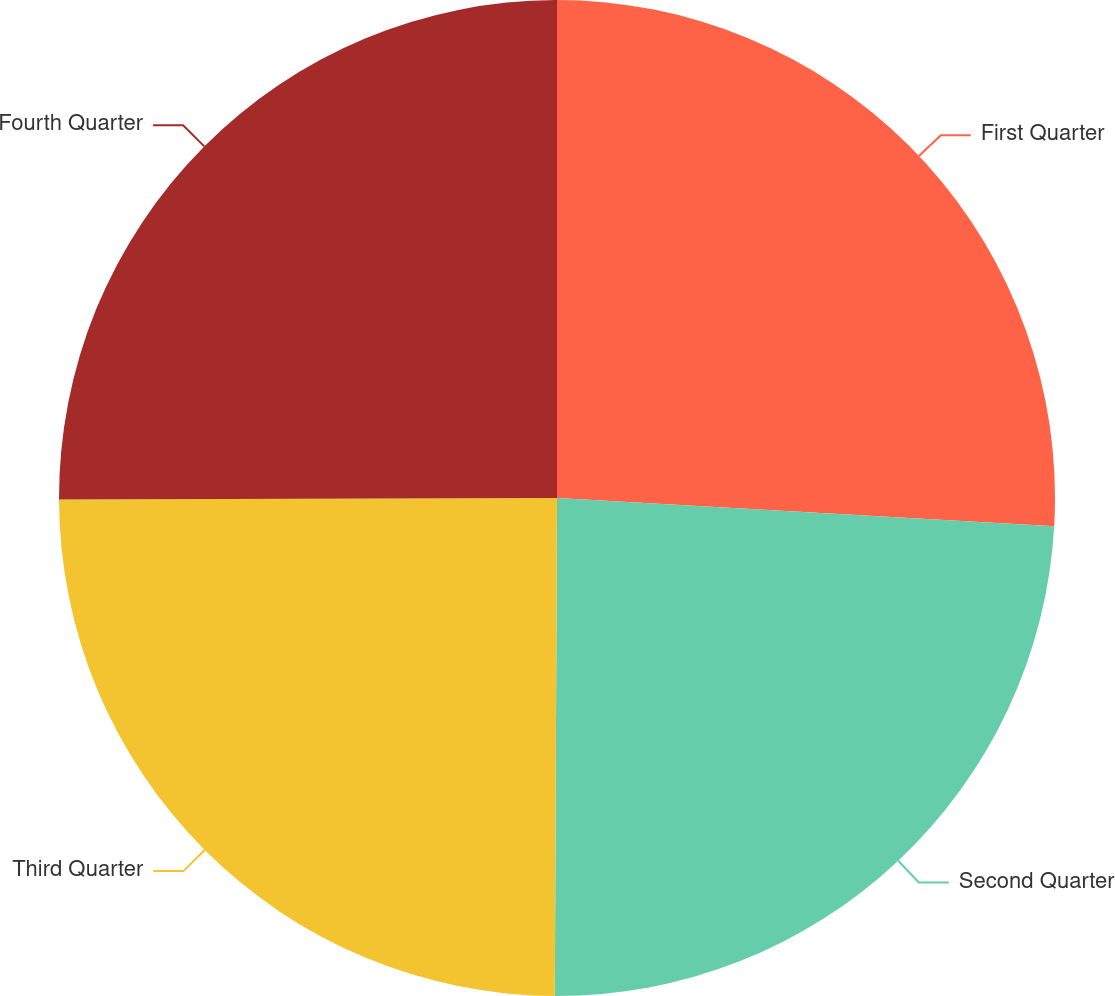<chart> <loc_0><loc_0><loc_500><loc_500><pie_chart><fcel>First Quarter<fcel>Second Quarter<fcel>Third Quarter<fcel>Fourth Quarter<nl><fcel>25.9%<fcel>24.17%<fcel>24.88%<fcel>25.05%<nl></chart> 